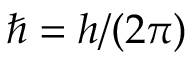Convert formula to latex. <formula><loc_0><loc_0><loc_500><loc_500>\hbar { = } h / ( 2 \pi )</formula> 